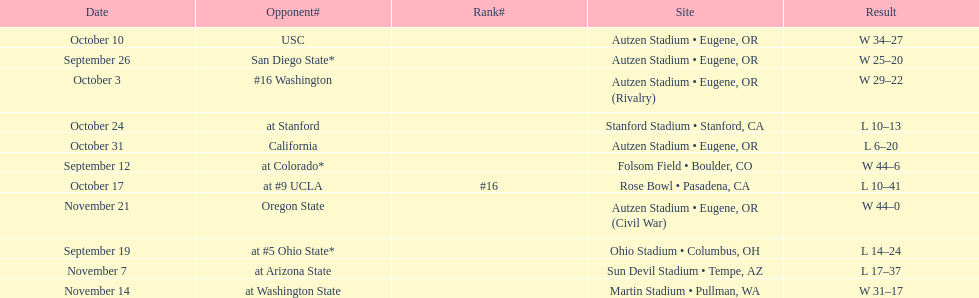Were the results of the game of november 14 above or below the results of the october 17 game? Above. 